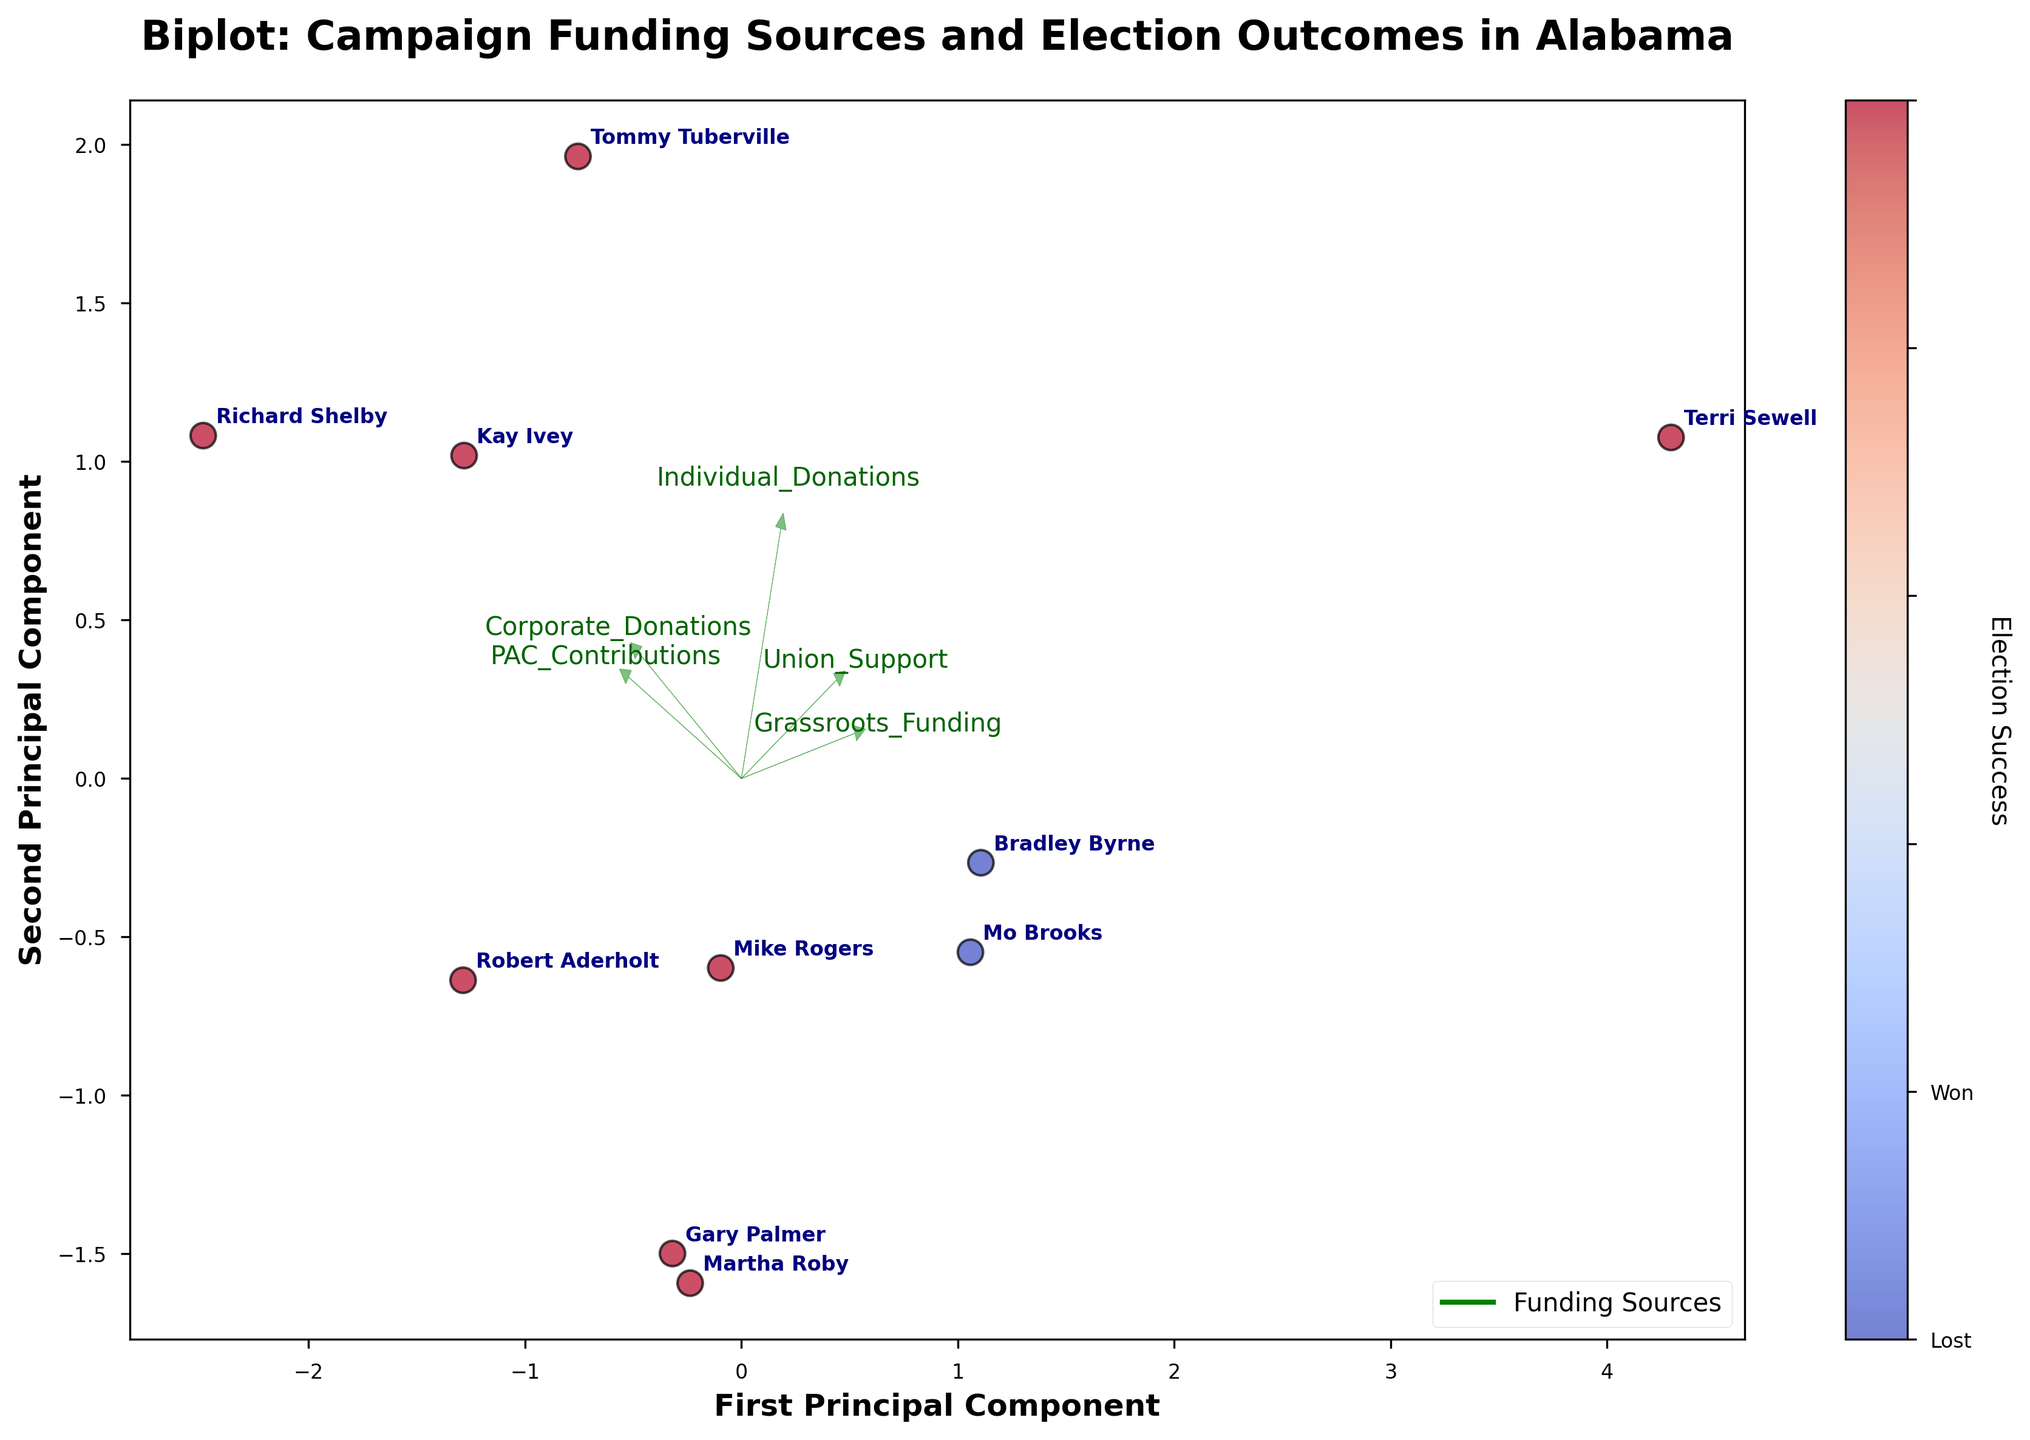What is the title of the chart? The title of the chart can be found at the top of the figure and it describes the main subject of the visualization. In this case, it indicates the relation between campaign funding sources and election outcomes.
Answer: "Biplot: Campaign Funding Sources and Election Outcomes in Alabama" How many components are displayed on the axes of the biplot? By looking at the labels of the axes, we can see that the figure shows the "First Principal Component" on the x-axis and the "Second Principal Component" on the y-axis, indicating two principal components.
Answer: Two Which candidate has the highest individual donation? We need to find the candidate's name positioned closest to the end of the arrow labeled "Individual_Donations" since the vector direction and magnitude give an indication of the donation values.
Answer: Tommy Tuberville Do more candidates win or lose their elections based on the data? By counting the number of data points with different colors (one color for winning and another for losing), we can determine which group is larger. The color legend on the side of the chart helps identify winners versus losers.
Answer: Win Which funding source seems to have the least impact on election success? By observing the magnitudes and directions of the feature vectors, the arrow with the smallest length represents the funding source with the least contribution to the principal components.
Answer: Union_Support Which two candidates are closest to each other in terms of their principal components? By identifying the data points that are nearest to each other on the plot, we can find the pair of candidates that are the closest.
Answer: Kay Ivey and Tommy Tuberville What is the meaning of the color bar on the right side of the plot? The color bar indicates the election outcomes, where different colors represent different results. We need to refer to the labels on the color bar to interpret it.
Answer: Election Success (Won or Lost) Which funding source aligns most closely with the first principal component? The direction and the magnitude of the arrows representing the funding sources determine their alignment with the principal component. We need to identify the arrow that has a significant projection on the x-axis of the plot.
Answer: Corporate_Donations What can be inferred about Bradley Byrne's election outcome in relation to his funding sources? Since Bradley Byrne is annotated on the plot, we can observe his position and relate it to the color representing his election success and his proximity to the funding source vectors.
Answer: Lost How do grassroots funding contributions relate to the second principal component? We observe the arrow labeled "Grassroots_Funding" in relation to the second principal component (y-axis). If it points primarily in the direction of the y-axis, it indicates a strong relation.
Answer: Strong relation (aligns closely with the second component) 